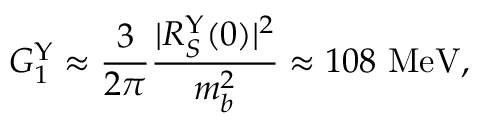<formula> <loc_0><loc_0><loc_500><loc_500>G _ { 1 } ^ { \Upsilon } \approx { \frac { 3 } { 2 \pi } } { \frac { | R _ { S } ^ { \Upsilon } ( 0 ) | ^ { 2 } } { m _ { b } ^ { 2 } } } \approx 1 0 8 M e V ,</formula> 